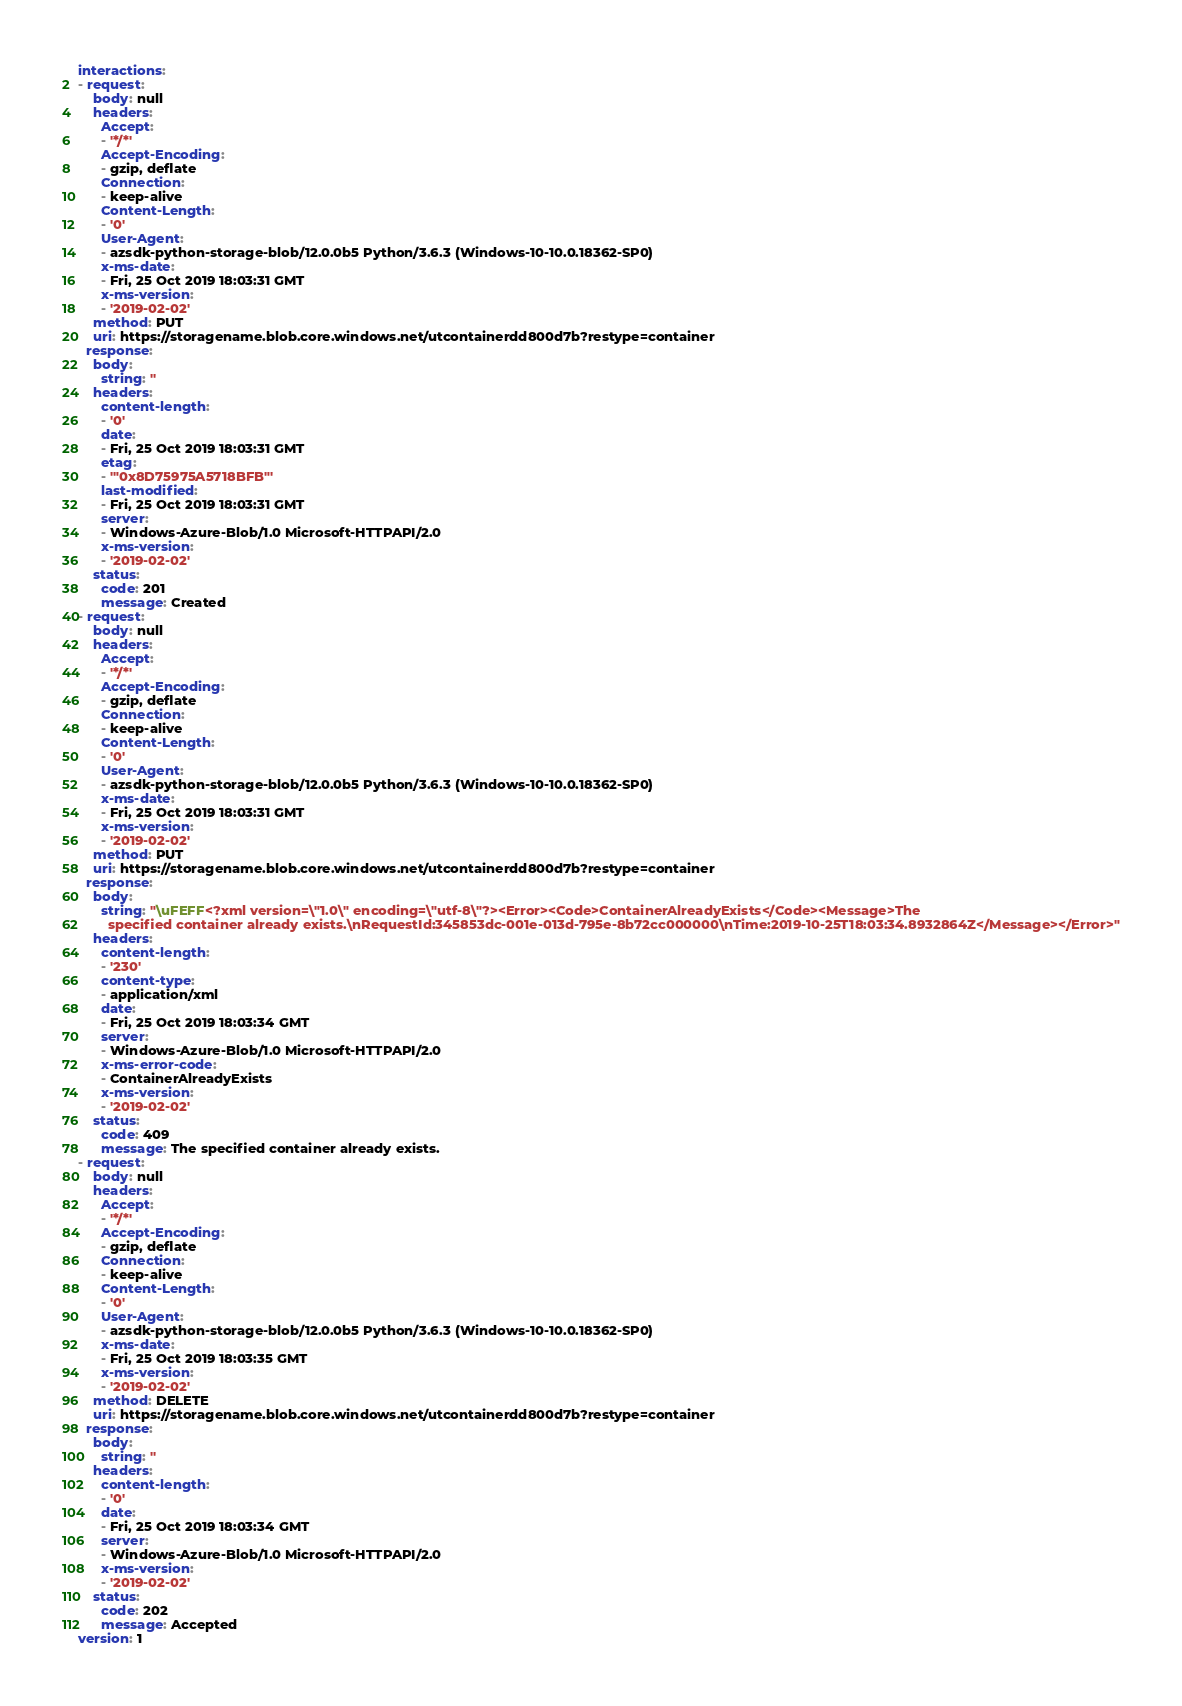<code> <loc_0><loc_0><loc_500><loc_500><_YAML_>interactions:
- request:
    body: null
    headers:
      Accept:
      - '*/*'
      Accept-Encoding:
      - gzip, deflate
      Connection:
      - keep-alive
      Content-Length:
      - '0'
      User-Agent:
      - azsdk-python-storage-blob/12.0.0b5 Python/3.6.3 (Windows-10-10.0.18362-SP0)
      x-ms-date:
      - Fri, 25 Oct 2019 18:03:31 GMT
      x-ms-version:
      - '2019-02-02'
    method: PUT
    uri: https://storagename.blob.core.windows.net/utcontainerdd800d7b?restype=container
  response:
    body:
      string: ''
    headers:
      content-length:
      - '0'
      date:
      - Fri, 25 Oct 2019 18:03:31 GMT
      etag:
      - '"0x8D75975A5718BFB"'
      last-modified:
      - Fri, 25 Oct 2019 18:03:31 GMT
      server:
      - Windows-Azure-Blob/1.0 Microsoft-HTTPAPI/2.0
      x-ms-version:
      - '2019-02-02'
    status:
      code: 201
      message: Created
- request:
    body: null
    headers:
      Accept:
      - '*/*'
      Accept-Encoding:
      - gzip, deflate
      Connection:
      - keep-alive
      Content-Length:
      - '0'
      User-Agent:
      - azsdk-python-storage-blob/12.0.0b5 Python/3.6.3 (Windows-10-10.0.18362-SP0)
      x-ms-date:
      - Fri, 25 Oct 2019 18:03:31 GMT
      x-ms-version:
      - '2019-02-02'
    method: PUT
    uri: https://storagename.blob.core.windows.net/utcontainerdd800d7b?restype=container
  response:
    body:
      string: "\uFEFF<?xml version=\"1.0\" encoding=\"utf-8\"?><Error><Code>ContainerAlreadyExists</Code><Message>The
        specified container already exists.\nRequestId:345853dc-001e-013d-795e-8b72cc000000\nTime:2019-10-25T18:03:34.8932864Z</Message></Error>"
    headers:
      content-length:
      - '230'
      content-type:
      - application/xml
      date:
      - Fri, 25 Oct 2019 18:03:34 GMT
      server:
      - Windows-Azure-Blob/1.0 Microsoft-HTTPAPI/2.0
      x-ms-error-code:
      - ContainerAlreadyExists
      x-ms-version:
      - '2019-02-02'
    status:
      code: 409
      message: The specified container already exists.
- request:
    body: null
    headers:
      Accept:
      - '*/*'
      Accept-Encoding:
      - gzip, deflate
      Connection:
      - keep-alive
      Content-Length:
      - '0'
      User-Agent:
      - azsdk-python-storage-blob/12.0.0b5 Python/3.6.3 (Windows-10-10.0.18362-SP0)
      x-ms-date:
      - Fri, 25 Oct 2019 18:03:35 GMT
      x-ms-version:
      - '2019-02-02'
    method: DELETE
    uri: https://storagename.blob.core.windows.net/utcontainerdd800d7b?restype=container
  response:
    body:
      string: ''
    headers:
      content-length:
      - '0'
      date:
      - Fri, 25 Oct 2019 18:03:34 GMT
      server:
      - Windows-Azure-Blob/1.0 Microsoft-HTTPAPI/2.0
      x-ms-version:
      - '2019-02-02'
    status:
      code: 202
      message: Accepted
version: 1
</code> 